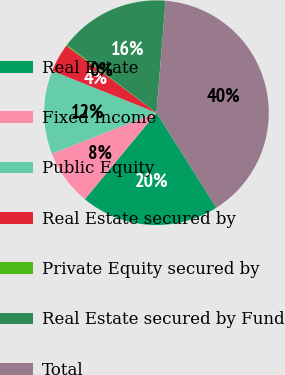<chart> <loc_0><loc_0><loc_500><loc_500><pie_chart><fcel>Real Estate<fcel>Fixed Income<fcel>Public Equity<fcel>Real Estate secured by<fcel>Private Equity secured by<fcel>Real Estate secured by Fund<fcel>Total<nl><fcel>19.95%<fcel>8.06%<fcel>12.02%<fcel>4.1%<fcel>0.13%<fcel>15.98%<fcel>39.76%<nl></chart> 